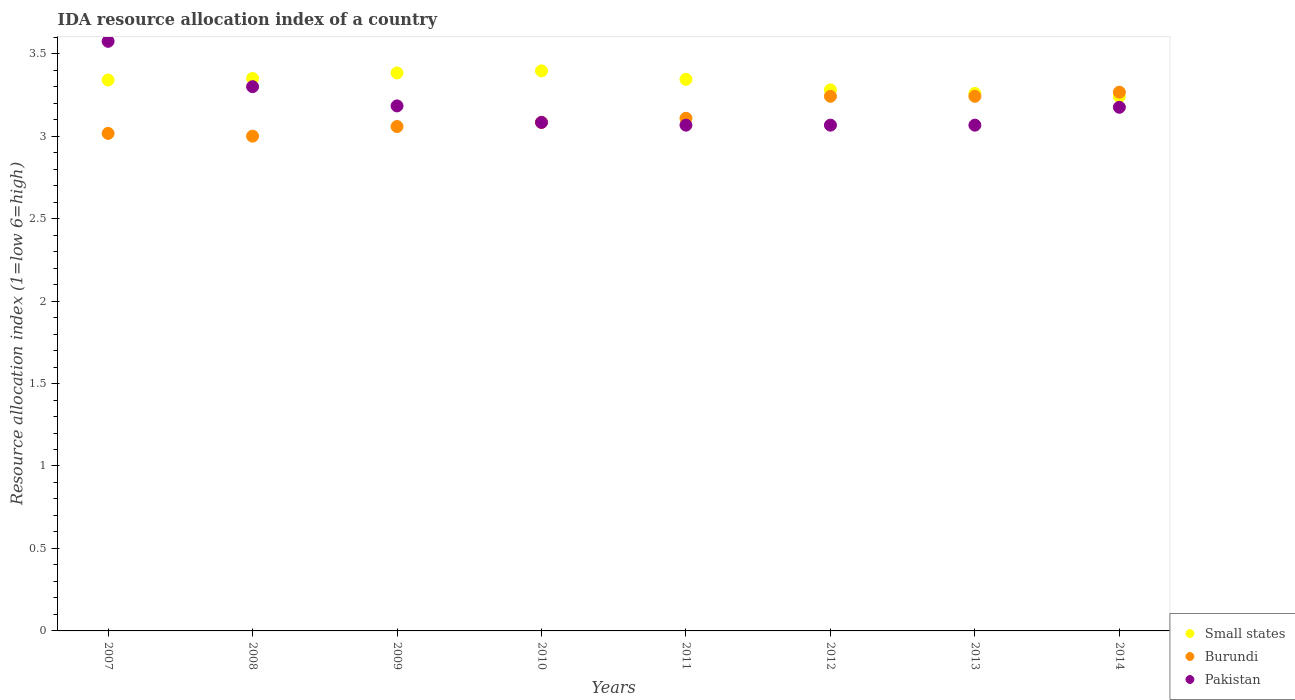How many different coloured dotlines are there?
Make the answer very short. 3. What is the IDA resource allocation index in Pakistan in 2012?
Provide a short and direct response. 3.07. Across all years, what is the maximum IDA resource allocation index in Burundi?
Keep it short and to the point. 3.27. Across all years, what is the minimum IDA resource allocation index in Burundi?
Your answer should be compact. 3. What is the total IDA resource allocation index in Pakistan in the graph?
Your answer should be compact. 25.52. What is the difference between the IDA resource allocation index in Burundi in 2008 and that in 2013?
Provide a short and direct response. -0.24. What is the difference between the IDA resource allocation index in Small states in 2007 and the IDA resource allocation index in Burundi in 2008?
Offer a terse response. 0.34. What is the average IDA resource allocation index in Burundi per year?
Provide a short and direct response. 3.13. In the year 2010, what is the difference between the IDA resource allocation index in Burundi and IDA resource allocation index in Pakistan?
Give a very brief answer. 0. What is the ratio of the IDA resource allocation index in Pakistan in 2009 to that in 2014?
Your answer should be very brief. 1. Is the IDA resource allocation index in Pakistan in 2008 less than that in 2014?
Offer a very short reply. No. Is the difference between the IDA resource allocation index in Burundi in 2011 and 2012 greater than the difference between the IDA resource allocation index in Pakistan in 2011 and 2012?
Ensure brevity in your answer.  No. What is the difference between the highest and the second highest IDA resource allocation index in Pakistan?
Offer a very short reply. 0.28. What is the difference between the highest and the lowest IDA resource allocation index in Small states?
Provide a succinct answer. 0.16. In how many years, is the IDA resource allocation index in Pakistan greater than the average IDA resource allocation index in Pakistan taken over all years?
Make the answer very short. 2. Is the sum of the IDA resource allocation index in Burundi in 2008 and 2013 greater than the maximum IDA resource allocation index in Pakistan across all years?
Offer a terse response. Yes. Is it the case that in every year, the sum of the IDA resource allocation index in Small states and IDA resource allocation index in Burundi  is greater than the IDA resource allocation index in Pakistan?
Your answer should be compact. Yes. Does the IDA resource allocation index in Pakistan monotonically increase over the years?
Your answer should be very brief. No. Is the IDA resource allocation index in Small states strictly greater than the IDA resource allocation index in Pakistan over the years?
Offer a terse response. No. How many dotlines are there?
Your response must be concise. 3. What is the difference between two consecutive major ticks on the Y-axis?
Provide a short and direct response. 0.5. Does the graph contain any zero values?
Make the answer very short. No. Does the graph contain grids?
Your response must be concise. No. Where does the legend appear in the graph?
Make the answer very short. Bottom right. How many legend labels are there?
Provide a short and direct response. 3. What is the title of the graph?
Provide a succinct answer. IDA resource allocation index of a country. Does "Malta" appear as one of the legend labels in the graph?
Offer a terse response. No. What is the label or title of the Y-axis?
Your answer should be very brief. Resource allocation index (1=low 6=high). What is the Resource allocation index (1=low 6=high) of Small states in 2007?
Give a very brief answer. 3.34. What is the Resource allocation index (1=low 6=high) of Burundi in 2007?
Your answer should be very brief. 3.02. What is the Resource allocation index (1=low 6=high) of Pakistan in 2007?
Offer a very short reply. 3.58. What is the Resource allocation index (1=low 6=high) of Small states in 2008?
Offer a very short reply. 3.35. What is the Resource allocation index (1=low 6=high) of Burundi in 2008?
Provide a succinct answer. 3. What is the Resource allocation index (1=low 6=high) in Pakistan in 2008?
Provide a short and direct response. 3.3. What is the Resource allocation index (1=low 6=high) of Small states in 2009?
Provide a short and direct response. 3.38. What is the Resource allocation index (1=low 6=high) of Burundi in 2009?
Offer a terse response. 3.06. What is the Resource allocation index (1=low 6=high) of Pakistan in 2009?
Your response must be concise. 3.18. What is the Resource allocation index (1=low 6=high) in Small states in 2010?
Ensure brevity in your answer.  3.4. What is the Resource allocation index (1=low 6=high) of Burundi in 2010?
Offer a terse response. 3.08. What is the Resource allocation index (1=low 6=high) of Pakistan in 2010?
Your response must be concise. 3.08. What is the Resource allocation index (1=low 6=high) in Small states in 2011?
Offer a very short reply. 3.34. What is the Resource allocation index (1=low 6=high) of Burundi in 2011?
Your answer should be compact. 3.11. What is the Resource allocation index (1=low 6=high) in Pakistan in 2011?
Give a very brief answer. 3.07. What is the Resource allocation index (1=low 6=high) of Small states in 2012?
Offer a very short reply. 3.28. What is the Resource allocation index (1=low 6=high) in Burundi in 2012?
Your answer should be very brief. 3.24. What is the Resource allocation index (1=low 6=high) of Pakistan in 2012?
Give a very brief answer. 3.07. What is the Resource allocation index (1=low 6=high) in Small states in 2013?
Offer a very short reply. 3.26. What is the Resource allocation index (1=low 6=high) of Burundi in 2013?
Offer a very short reply. 3.24. What is the Resource allocation index (1=low 6=high) of Pakistan in 2013?
Give a very brief answer. 3.07. What is the Resource allocation index (1=low 6=high) of Small states in 2014?
Offer a very short reply. 3.24. What is the Resource allocation index (1=low 6=high) in Burundi in 2014?
Keep it short and to the point. 3.27. What is the Resource allocation index (1=low 6=high) in Pakistan in 2014?
Offer a very short reply. 3.17. Across all years, what is the maximum Resource allocation index (1=low 6=high) in Small states?
Your answer should be compact. 3.4. Across all years, what is the maximum Resource allocation index (1=low 6=high) of Burundi?
Your answer should be very brief. 3.27. Across all years, what is the maximum Resource allocation index (1=low 6=high) of Pakistan?
Keep it short and to the point. 3.58. Across all years, what is the minimum Resource allocation index (1=low 6=high) in Small states?
Your answer should be very brief. 3.24. Across all years, what is the minimum Resource allocation index (1=low 6=high) of Pakistan?
Your answer should be very brief. 3.07. What is the total Resource allocation index (1=low 6=high) of Small states in the graph?
Your answer should be compact. 26.59. What is the total Resource allocation index (1=low 6=high) of Burundi in the graph?
Keep it short and to the point. 25.02. What is the total Resource allocation index (1=low 6=high) of Pakistan in the graph?
Provide a succinct answer. 25.52. What is the difference between the Resource allocation index (1=low 6=high) in Small states in 2007 and that in 2008?
Ensure brevity in your answer.  -0.01. What is the difference between the Resource allocation index (1=low 6=high) in Burundi in 2007 and that in 2008?
Your answer should be compact. 0.02. What is the difference between the Resource allocation index (1=low 6=high) of Pakistan in 2007 and that in 2008?
Keep it short and to the point. 0.28. What is the difference between the Resource allocation index (1=low 6=high) of Small states in 2007 and that in 2009?
Ensure brevity in your answer.  -0.04. What is the difference between the Resource allocation index (1=low 6=high) in Burundi in 2007 and that in 2009?
Provide a succinct answer. -0.04. What is the difference between the Resource allocation index (1=low 6=high) in Pakistan in 2007 and that in 2009?
Offer a very short reply. 0.39. What is the difference between the Resource allocation index (1=low 6=high) of Small states in 2007 and that in 2010?
Offer a terse response. -0.06. What is the difference between the Resource allocation index (1=low 6=high) of Burundi in 2007 and that in 2010?
Ensure brevity in your answer.  -0.07. What is the difference between the Resource allocation index (1=low 6=high) in Pakistan in 2007 and that in 2010?
Your answer should be compact. 0.49. What is the difference between the Resource allocation index (1=low 6=high) in Small states in 2007 and that in 2011?
Ensure brevity in your answer.  -0. What is the difference between the Resource allocation index (1=low 6=high) in Burundi in 2007 and that in 2011?
Offer a terse response. -0.09. What is the difference between the Resource allocation index (1=low 6=high) in Pakistan in 2007 and that in 2011?
Give a very brief answer. 0.51. What is the difference between the Resource allocation index (1=low 6=high) in Small states in 2007 and that in 2012?
Offer a terse response. 0.06. What is the difference between the Resource allocation index (1=low 6=high) in Burundi in 2007 and that in 2012?
Your answer should be compact. -0.23. What is the difference between the Resource allocation index (1=low 6=high) in Pakistan in 2007 and that in 2012?
Your answer should be very brief. 0.51. What is the difference between the Resource allocation index (1=low 6=high) of Small states in 2007 and that in 2013?
Ensure brevity in your answer.  0.08. What is the difference between the Resource allocation index (1=low 6=high) of Burundi in 2007 and that in 2013?
Offer a terse response. -0.23. What is the difference between the Resource allocation index (1=low 6=high) in Pakistan in 2007 and that in 2013?
Your answer should be compact. 0.51. What is the difference between the Resource allocation index (1=low 6=high) of Small states in 2007 and that in 2014?
Provide a succinct answer. 0.1. What is the difference between the Resource allocation index (1=low 6=high) in Burundi in 2007 and that in 2014?
Offer a very short reply. -0.25. What is the difference between the Resource allocation index (1=low 6=high) in Pakistan in 2007 and that in 2014?
Make the answer very short. 0.4. What is the difference between the Resource allocation index (1=low 6=high) of Small states in 2008 and that in 2009?
Keep it short and to the point. -0.03. What is the difference between the Resource allocation index (1=low 6=high) in Burundi in 2008 and that in 2009?
Provide a short and direct response. -0.06. What is the difference between the Resource allocation index (1=low 6=high) of Pakistan in 2008 and that in 2009?
Your response must be concise. 0.12. What is the difference between the Resource allocation index (1=low 6=high) of Small states in 2008 and that in 2010?
Your answer should be compact. -0.05. What is the difference between the Resource allocation index (1=low 6=high) of Burundi in 2008 and that in 2010?
Offer a terse response. -0.08. What is the difference between the Resource allocation index (1=low 6=high) of Pakistan in 2008 and that in 2010?
Give a very brief answer. 0.22. What is the difference between the Resource allocation index (1=low 6=high) in Small states in 2008 and that in 2011?
Your answer should be very brief. 0.01. What is the difference between the Resource allocation index (1=low 6=high) in Burundi in 2008 and that in 2011?
Offer a terse response. -0.11. What is the difference between the Resource allocation index (1=low 6=high) in Pakistan in 2008 and that in 2011?
Keep it short and to the point. 0.23. What is the difference between the Resource allocation index (1=low 6=high) in Small states in 2008 and that in 2012?
Offer a very short reply. 0.07. What is the difference between the Resource allocation index (1=low 6=high) in Burundi in 2008 and that in 2012?
Your answer should be very brief. -0.24. What is the difference between the Resource allocation index (1=low 6=high) of Pakistan in 2008 and that in 2012?
Provide a succinct answer. 0.23. What is the difference between the Resource allocation index (1=low 6=high) in Small states in 2008 and that in 2013?
Offer a terse response. 0.09. What is the difference between the Resource allocation index (1=low 6=high) in Burundi in 2008 and that in 2013?
Keep it short and to the point. -0.24. What is the difference between the Resource allocation index (1=low 6=high) in Pakistan in 2008 and that in 2013?
Offer a terse response. 0.23. What is the difference between the Resource allocation index (1=low 6=high) of Small states in 2008 and that in 2014?
Give a very brief answer. 0.11. What is the difference between the Resource allocation index (1=low 6=high) of Burundi in 2008 and that in 2014?
Give a very brief answer. -0.27. What is the difference between the Resource allocation index (1=low 6=high) in Pakistan in 2008 and that in 2014?
Keep it short and to the point. 0.12. What is the difference between the Resource allocation index (1=low 6=high) of Small states in 2009 and that in 2010?
Your answer should be very brief. -0.01. What is the difference between the Resource allocation index (1=low 6=high) in Burundi in 2009 and that in 2010?
Your response must be concise. -0.03. What is the difference between the Resource allocation index (1=low 6=high) of Pakistan in 2009 and that in 2010?
Provide a short and direct response. 0.1. What is the difference between the Resource allocation index (1=low 6=high) of Small states in 2009 and that in 2011?
Your answer should be compact. 0.04. What is the difference between the Resource allocation index (1=low 6=high) of Pakistan in 2009 and that in 2011?
Provide a short and direct response. 0.12. What is the difference between the Resource allocation index (1=low 6=high) in Small states in 2009 and that in 2012?
Give a very brief answer. 0.1. What is the difference between the Resource allocation index (1=low 6=high) of Burundi in 2009 and that in 2012?
Your response must be concise. -0.18. What is the difference between the Resource allocation index (1=low 6=high) in Pakistan in 2009 and that in 2012?
Your response must be concise. 0.12. What is the difference between the Resource allocation index (1=low 6=high) in Small states in 2009 and that in 2013?
Make the answer very short. 0.12. What is the difference between the Resource allocation index (1=low 6=high) in Burundi in 2009 and that in 2013?
Offer a terse response. -0.18. What is the difference between the Resource allocation index (1=low 6=high) in Pakistan in 2009 and that in 2013?
Offer a terse response. 0.12. What is the difference between the Resource allocation index (1=low 6=high) of Small states in 2009 and that in 2014?
Provide a short and direct response. 0.14. What is the difference between the Resource allocation index (1=low 6=high) of Burundi in 2009 and that in 2014?
Keep it short and to the point. -0.21. What is the difference between the Resource allocation index (1=low 6=high) of Pakistan in 2009 and that in 2014?
Make the answer very short. 0.01. What is the difference between the Resource allocation index (1=low 6=high) in Small states in 2010 and that in 2011?
Your answer should be compact. 0.05. What is the difference between the Resource allocation index (1=low 6=high) in Burundi in 2010 and that in 2011?
Offer a very short reply. -0.03. What is the difference between the Resource allocation index (1=low 6=high) in Pakistan in 2010 and that in 2011?
Give a very brief answer. 0.02. What is the difference between the Resource allocation index (1=low 6=high) in Small states in 2010 and that in 2012?
Keep it short and to the point. 0.12. What is the difference between the Resource allocation index (1=low 6=high) in Burundi in 2010 and that in 2012?
Your answer should be very brief. -0.16. What is the difference between the Resource allocation index (1=low 6=high) in Pakistan in 2010 and that in 2012?
Your response must be concise. 0.02. What is the difference between the Resource allocation index (1=low 6=high) in Small states in 2010 and that in 2013?
Offer a terse response. 0.14. What is the difference between the Resource allocation index (1=low 6=high) of Burundi in 2010 and that in 2013?
Your answer should be very brief. -0.16. What is the difference between the Resource allocation index (1=low 6=high) of Pakistan in 2010 and that in 2013?
Provide a succinct answer. 0.02. What is the difference between the Resource allocation index (1=low 6=high) in Small states in 2010 and that in 2014?
Offer a terse response. 0.16. What is the difference between the Resource allocation index (1=low 6=high) of Burundi in 2010 and that in 2014?
Provide a succinct answer. -0.18. What is the difference between the Resource allocation index (1=low 6=high) in Pakistan in 2010 and that in 2014?
Keep it short and to the point. -0.09. What is the difference between the Resource allocation index (1=low 6=high) of Small states in 2011 and that in 2012?
Offer a very short reply. 0.06. What is the difference between the Resource allocation index (1=low 6=high) in Burundi in 2011 and that in 2012?
Make the answer very short. -0.13. What is the difference between the Resource allocation index (1=low 6=high) of Small states in 2011 and that in 2013?
Your answer should be very brief. 0.09. What is the difference between the Resource allocation index (1=low 6=high) in Burundi in 2011 and that in 2013?
Your response must be concise. -0.13. What is the difference between the Resource allocation index (1=low 6=high) in Pakistan in 2011 and that in 2013?
Your response must be concise. 0. What is the difference between the Resource allocation index (1=low 6=high) in Small states in 2011 and that in 2014?
Provide a succinct answer. 0.1. What is the difference between the Resource allocation index (1=low 6=high) in Burundi in 2011 and that in 2014?
Your response must be concise. -0.16. What is the difference between the Resource allocation index (1=low 6=high) in Pakistan in 2011 and that in 2014?
Make the answer very short. -0.11. What is the difference between the Resource allocation index (1=low 6=high) of Small states in 2012 and that in 2013?
Offer a terse response. 0.02. What is the difference between the Resource allocation index (1=low 6=high) in Small states in 2012 and that in 2014?
Provide a succinct answer. 0.04. What is the difference between the Resource allocation index (1=low 6=high) in Burundi in 2012 and that in 2014?
Provide a short and direct response. -0.03. What is the difference between the Resource allocation index (1=low 6=high) in Pakistan in 2012 and that in 2014?
Ensure brevity in your answer.  -0.11. What is the difference between the Resource allocation index (1=low 6=high) in Small states in 2013 and that in 2014?
Your answer should be very brief. 0.02. What is the difference between the Resource allocation index (1=low 6=high) of Burundi in 2013 and that in 2014?
Provide a short and direct response. -0.03. What is the difference between the Resource allocation index (1=low 6=high) in Pakistan in 2013 and that in 2014?
Your answer should be compact. -0.11. What is the difference between the Resource allocation index (1=low 6=high) of Small states in 2007 and the Resource allocation index (1=low 6=high) of Burundi in 2008?
Offer a very short reply. 0.34. What is the difference between the Resource allocation index (1=low 6=high) of Small states in 2007 and the Resource allocation index (1=low 6=high) of Pakistan in 2008?
Your answer should be very brief. 0.04. What is the difference between the Resource allocation index (1=low 6=high) of Burundi in 2007 and the Resource allocation index (1=low 6=high) of Pakistan in 2008?
Your response must be concise. -0.28. What is the difference between the Resource allocation index (1=low 6=high) of Small states in 2007 and the Resource allocation index (1=low 6=high) of Burundi in 2009?
Provide a succinct answer. 0.28. What is the difference between the Resource allocation index (1=low 6=high) of Small states in 2007 and the Resource allocation index (1=low 6=high) of Pakistan in 2009?
Your response must be concise. 0.16. What is the difference between the Resource allocation index (1=low 6=high) of Burundi in 2007 and the Resource allocation index (1=low 6=high) of Pakistan in 2009?
Give a very brief answer. -0.17. What is the difference between the Resource allocation index (1=low 6=high) of Small states in 2007 and the Resource allocation index (1=low 6=high) of Burundi in 2010?
Your answer should be very brief. 0.26. What is the difference between the Resource allocation index (1=low 6=high) in Small states in 2007 and the Resource allocation index (1=low 6=high) in Pakistan in 2010?
Provide a succinct answer. 0.26. What is the difference between the Resource allocation index (1=low 6=high) of Burundi in 2007 and the Resource allocation index (1=low 6=high) of Pakistan in 2010?
Your response must be concise. -0.07. What is the difference between the Resource allocation index (1=low 6=high) in Small states in 2007 and the Resource allocation index (1=low 6=high) in Burundi in 2011?
Ensure brevity in your answer.  0.23. What is the difference between the Resource allocation index (1=low 6=high) of Small states in 2007 and the Resource allocation index (1=low 6=high) of Pakistan in 2011?
Your answer should be compact. 0.27. What is the difference between the Resource allocation index (1=low 6=high) of Small states in 2007 and the Resource allocation index (1=low 6=high) of Burundi in 2012?
Offer a very short reply. 0.1. What is the difference between the Resource allocation index (1=low 6=high) in Small states in 2007 and the Resource allocation index (1=low 6=high) in Pakistan in 2012?
Offer a terse response. 0.27. What is the difference between the Resource allocation index (1=low 6=high) of Burundi in 2007 and the Resource allocation index (1=low 6=high) of Pakistan in 2012?
Provide a succinct answer. -0.05. What is the difference between the Resource allocation index (1=low 6=high) of Small states in 2007 and the Resource allocation index (1=low 6=high) of Burundi in 2013?
Offer a very short reply. 0.1. What is the difference between the Resource allocation index (1=low 6=high) in Small states in 2007 and the Resource allocation index (1=low 6=high) in Pakistan in 2013?
Your answer should be very brief. 0.27. What is the difference between the Resource allocation index (1=low 6=high) in Burundi in 2007 and the Resource allocation index (1=low 6=high) in Pakistan in 2013?
Provide a short and direct response. -0.05. What is the difference between the Resource allocation index (1=low 6=high) of Small states in 2007 and the Resource allocation index (1=low 6=high) of Burundi in 2014?
Give a very brief answer. 0.07. What is the difference between the Resource allocation index (1=low 6=high) of Small states in 2007 and the Resource allocation index (1=low 6=high) of Pakistan in 2014?
Ensure brevity in your answer.  0.17. What is the difference between the Resource allocation index (1=low 6=high) of Burundi in 2007 and the Resource allocation index (1=low 6=high) of Pakistan in 2014?
Provide a short and direct response. -0.16. What is the difference between the Resource allocation index (1=low 6=high) in Small states in 2008 and the Resource allocation index (1=low 6=high) in Burundi in 2009?
Keep it short and to the point. 0.29. What is the difference between the Resource allocation index (1=low 6=high) in Small states in 2008 and the Resource allocation index (1=low 6=high) in Pakistan in 2009?
Give a very brief answer. 0.17. What is the difference between the Resource allocation index (1=low 6=high) of Burundi in 2008 and the Resource allocation index (1=low 6=high) of Pakistan in 2009?
Ensure brevity in your answer.  -0.18. What is the difference between the Resource allocation index (1=low 6=high) in Small states in 2008 and the Resource allocation index (1=low 6=high) in Burundi in 2010?
Ensure brevity in your answer.  0.27. What is the difference between the Resource allocation index (1=low 6=high) in Small states in 2008 and the Resource allocation index (1=low 6=high) in Pakistan in 2010?
Offer a terse response. 0.27. What is the difference between the Resource allocation index (1=low 6=high) of Burundi in 2008 and the Resource allocation index (1=low 6=high) of Pakistan in 2010?
Your answer should be compact. -0.08. What is the difference between the Resource allocation index (1=low 6=high) in Small states in 2008 and the Resource allocation index (1=low 6=high) in Burundi in 2011?
Offer a very short reply. 0.24. What is the difference between the Resource allocation index (1=low 6=high) of Small states in 2008 and the Resource allocation index (1=low 6=high) of Pakistan in 2011?
Provide a succinct answer. 0.28. What is the difference between the Resource allocation index (1=low 6=high) in Burundi in 2008 and the Resource allocation index (1=low 6=high) in Pakistan in 2011?
Ensure brevity in your answer.  -0.07. What is the difference between the Resource allocation index (1=low 6=high) of Small states in 2008 and the Resource allocation index (1=low 6=high) of Burundi in 2012?
Your answer should be very brief. 0.11. What is the difference between the Resource allocation index (1=low 6=high) in Small states in 2008 and the Resource allocation index (1=low 6=high) in Pakistan in 2012?
Your answer should be compact. 0.28. What is the difference between the Resource allocation index (1=low 6=high) of Burundi in 2008 and the Resource allocation index (1=low 6=high) of Pakistan in 2012?
Make the answer very short. -0.07. What is the difference between the Resource allocation index (1=low 6=high) in Small states in 2008 and the Resource allocation index (1=low 6=high) in Burundi in 2013?
Provide a succinct answer. 0.11. What is the difference between the Resource allocation index (1=low 6=high) in Small states in 2008 and the Resource allocation index (1=low 6=high) in Pakistan in 2013?
Your answer should be compact. 0.28. What is the difference between the Resource allocation index (1=low 6=high) of Burundi in 2008 and the Resource allocation index (1=low 6=high) of Pakistan in 2013?
Offer a terse response. -0.07. What is the difference between the Resource allocation index (1=low 6=high) of Small states in 2008 and the Resource allocation index (1=low 6=high) of Burundi in 2014?
Your answer should be very brief. 0.08. What is the difference between the Resource allocation index (1=low 6=high) in Small states in 2008 and the Resource allocation index (1=low 6=high) in Pakistan in 2014?
Ensure brevity in your answer.  0.17. What is the difference between the Resource allocation index (1=low 6=high) in Burundi in 2008 and the Resource allocation index (1=low 6=high) in Pakistan in 2014?
Make the answer very short. -0.17. What is the difference between the Resource allocation index (1=low 6=high) of Small states in 2009 and the Resource allocation index (1=low 6=high) of Burundi in 2010?
Ensure brevity in your answer.  0.3. What is the difference between the Resource allocation index (1=low 6=high) in Small states in 2009 and the Resource allocation index (1=low 6=high) in Pakistan in 2010?
Provide a short and direct response. 0.3. What is the difference between the Resource allocation index (1=low 6=high) in Burundi in 2009 and the Resource allocation index (1=low 6=high) in Pakistan in 2010?
Your answer should be compact. -0.03. What is the difference between the Resource allocation index (1=low 6=high) in Small states in 2009 and the Resource allocation index (1=low 6=high) in Burundi in 2011?
Keep it short and to the point. 0.28. What is the difference between the Resource allocation index (1=low 6=high) in Small states in 2009 and the Resource allocation index (1=low 6=high) in Pakistan in 2011?
Offer a very short reply. 0.32. What is the difference between the Resource allocation index (1=low 6=high) in Burundi in 2009 and the Resource allocation index (1=low 6=high) in Pakistan in 2011?
Your answer should be compact. -0.01. What is the difference between the Resource allocation index (1=low 6=high) of Small states in 2009 and the Resource allocation index (1=low 6=high) of Burundi in 2012?
Your answer should be compact. 0.14. What is the difference between the Resource allocation index (1=low 6=high) of Small states in 2009 and the Resource allocation index (1=low 6=high) of Pakistan in 2012?
Make the answer very short. 0.32. What is the difference between the Resource allocation index (1=low 6=high) in Burundi in 2009 and the Resource allocation index (1=low 6=high) in Pakistan in 2012?
Keep it short and to the point. -0.01. What is the difference between the Resource allocation index (1=low 6=high) of Small states in 2009 and the Resource allocation index (1=low 6=high) of Burundi in 2013?
Offer a terse response. 0.14. What is the difference between the Resource allocation index (1=low 6=high) in Small states in 2009 and the Resource allocation index (1=low 6=high) in Pakistan in 2013?
Keep it short and to the point. 0.32. What is the difference between the Resource allocation index (1=low 6=high) of Burundi in 2009 and the Resource allocation index (1=low 6=high) of Pakistan in 2013?
Keep it short and to the point. -0.01. What is the difference between the Resource allocation index (1=low 6=high) in Small states in 2009 and the Resource allocation index (1=low 6=high) in Burundi in 2014?
Offer a terse response. 0.12. What is the difference between the Resource allocation index (1=low 6=high) of Small states in 2009 and the Resource allocation index (1=low 6=high) of Pakistan in 2014?
Offer a terse response. 0.21. What is the difference between the Resource allocation index (1=low 6=high) in Burundi in 2009 and the Resource allocation index (1=low 6=high) in Pakistan in 2014?
Your response must be concise. -0.12. What is the difference between the Resource allocation index (1=low 6=high) of Small states in 2010 and the Resource allocation index (1=low 6=high) of Burundi in 2011?
Your response must be concise. 0.29. What is the difference between the Resource allocation index (1=low 6=high) of Small states in 2010 and the Resource allocation index (1=low 6=high) of Pakistan in 2011?
Keep it short and to the point. 0.33. What is the difference between the Resource allocation index (1=low 6=high) in Burundi in 2010 and the Resource allocation index (1=low 6=high) in Pakistan in 2011?
Your answer should be very brief. 0.02. What is the difference between the Resource allocation index (1=low 6=high) of Small states in 2010 and the Resource allocation index (1=low 6=high) of Burundi in 2012?
Provide a succinct answer. 0.15. What is the difference between the Resource allocation index (1=low 6=high) in Small states in 2010 and the Resource allocation index (1=low 6=high) in Pakistan in 2012?
Provide a succinct answer. 0.33. What is the difference between the Resource allocation index (1=low 6=high) in Burundi in 2010 and the Resource allocation index (1=low 6=high) in Pakistan in 2012?
Ensure brevity in your answer.  0.02. What is the difference between the Resource allocation index (1=low 6=high) in Small states in 2010 and the Resource allocation index (1=low 6=high) in Burundi in 2013?
Give a very brief answer. 0.15. What is the difference between the Resource allocation index (1=low 6=high) of Small states in 2010 and the Resource allocation index (1=low 6=high) of Pakistan in 2013?
Give a very brief answer. 0.33. What is the difference between the Resource allocation index (1=low 6=high) of Burundi in 2010 and the Resource allocation index (1=low 6=high) of Pakistan in 2013?
Ensure brevity in your answer.  0.02. What is the difference between the Resource allocation index (1=low 6=high) in Small states in 2010 and the Resource allocation index (1=low 6=high) in Burundi in 2014?
Offer a terse response. 0.13. What is the difference between the Resource allocation index (1=low 6=high) in Small states in 2010 and the Resource allocation index (1=low 6=high) in Pakistan in 2014?
Offer a very short reply. 0.22. What is the difference between the Resource allocation index (1=low 6=high) of Burundi in 2010 and the Resource allocation index (1=low 6=high) of Pakistan in 2014?
Make the answer very short. -0.09. What is the difference between the Resource allocation index (1=low 6=high) in Small states in 2011 and the Resource allocation index (1=low 6=high) in Burundi in 2012?
Your answer should be compact. 0.1. What is the difference between the Resource allocation index (1=low 6=high) of Small states in 2011 and the Resource allocation index (1=low 6=high) of Pakistan in 2012?
Give a very brief answer. 0.28. What is the difference between the Resource allocation index (1=low 6=high) of Burundi in 2011 and the Resource allocation index (1=low 6=high) of Pakistan in 2012?
Offer a very short reply. 0.04. What is the difference between the Resource allocation index (1=low 6=high) in Small states in 2011 and the Resource allocation index (1=low 6=high) in Burundi in 2013?
Your response must be concise. 0.1. What is the difference between the Resource allocation index (1=low 6=high) in Small states in 2011 and the Resource allocation index (1=low 6=high) in Pakistan in 2013?
Give a very brief answer. 0.28. What is the difference between the Resource allocation index (1=low 6=high) of Burundi in 2011 and the Resource allocation index (1=low 6=high) of Pakistan in 2013?
Ensure brevity in your answer.  0.04. What is the difference between the Resource allocation index (1=low 6=high) in Small states in 2011 and the Resource allocation index (1=low 6=high) in Burundi in 2014?
Offer a terse response. 0.08. What is the difference between the Resource allocation index (1=low 6=high) of Small states in 2011 and the Resource allocation index (1=low 6=high) of Pakistan in 2014?
Provide a short and direct response. 0.17. What is the difference between the Resource allocation index (1=low 6=high) in Burundi in 2011 and the Resource allocation index (1=low 6=high) in Pakistan in 2014?
Your response must be concise. -0.07. What is the difference between the Resource allocation index (1=low 6=high) of Small states in 2012 and the Resource allocation index (1=low 6=high) of Burundi in 2013?
Ensure brevity in your answer.  0.04. What is the difference between the Resource allocation index (1=low 6=high) of Small states in 2012 and the Resource allocation index (1=low 6=high) of Pakistan in 2013?
Offer a terse response. 0.21. What is the difference between the Resource allocation index (1=low 6=high) of Burundi in 2012 and the Resource allocation index (1=low 6=high) of Pakistan in 2013?
Keep it short and to the point. 0.17. What is the difference between the Resource allocation index (1=low 6=high) in Small states in 2012 and the Resource allocation index (1=low 6=high) in Burundi in 2014?
Ensure brevity in your answer.  0.01. What is the difference between the Resource allocation index (1=low 6=high) in Small states in 2012 and the Resource allocation index (1=low 6=high) in Pakistan in 2014?
Provide a succinct answer. 0.11. What is the difference between the Resource allocation index (1=low 6=high) in Burundi in 2012 and the Resource allocation index (1=low 6=high) in Pakistan in 2014?
Your answer should be very brief. 0.07. What is the difference between the Resource allocation index (1=low 6=high) in Small states in 2013 and the Resource allocation index (1=low 6=high) in Burundi in 2014?
Your answer should be very brief. -0.01. What is the difference between the Resource allocation index (1=low 6=high) of Small states in 2013 and the Resource allocation index (1=low 6=high) of Pakistan in 2014?
Your response must be concise. 0.08. What is the difference between the Resource allocation index (1=low 6=high) of Burundi in 2013 and the Resource allocation index (1=low 6=high) of Pakistan in 2014?
Keep it short and to the point. 0.07. What is the average Resource allocation index (1=low 6=high) of Small states per year?
Make the answer very short. 3.32. What is the average Resource allocation index (1=low 6=high) of Burundi per year?
Your answer should be very brief. 3.13. What is the average Resource allocation index (1=low 6=high) of Pakistan per year?
Your answer should be compact. 3.19. In the year 2007, what is the difference between the Resource allocation index (1=low 6=high) of Small states and Resource allocation index (1=low 6=high) of Burundi?
Offer a very short reply. 0.32. In the year 2007, what is the difference between the Resource allocation index (1=low 6=high) of Small states and Resource allocation index (1=low 6=high) of Pakistan?
Give a very brief answer. -0.23. In the year 2007, what is the difference between the Resource allocation index (1=low 6=high) in Burundi and Resource allocation index (1=low 6=high) in Pakistan?
Make the answer very short. -0.56. In the year 2009, what is the difference between the Resource allocation index (1=low 6=high) in Small states and Resource allocation index (1=low 6=high) in Burundi?
Make the answer very short. 0.33. In the year 2009, what is the difference between the Resource allocation index (1=low 6=high) of Burundi and Resource allocation index (1=low 6=high) of Pakistan?
Ensure brevity in your answer.  -0.12. In the year 2010, what is the difference between the Resource allocation index (1=low 6=high) in Small states and Resource allocation index (1=low 6=high) in Burundi?
Offer a terse response. 0.31. In the year 2010, what is the difference between the Resource allocation index (1=low 6=high) of Small states and Resource allocation index (1=low 6=high) of Pakistan?
Ensure brevity in your answer.  0.31. In the year 2010, what is the difference between the Resource allocation index (1=low 6=high) in Burundi and Resource allocation index (1=low 6=high) in Pakistan?
Offer a terse response. 0. In the year 2011, what is the difference between the Resource allocation index (1=low 6=high) in Small states and Resource allocation index (1=low 6=high) in Burundi?
Provide a succinct answer. 0.24. In the year 2011, what is the difference between the Resource allocation index (1=low 6=high) of Small states and Resource allocation index (1=low 6=high) of Pakistan?
Provide a succinct answer. 0.28. In the year 2011, what is the difference between the Resource allocation index (1=low 6=high) of Burundi and Resource allocation index (1=low 6=high) of Pakistan?
Provide a short and direct response. 0.04. In the year 2012, what is the difference between the Resource allocation index (1=low 6=high) of Small states and Resource allocation index (1=low 6=high) of Burundi?
Ensure brevity in your answer.  0.04. In the year 2012, what is the difference between the Resource allocation index (1=low 6=high) of Small states and Resource allocation index (1=low 6=high) of Pakistan?
Give a very brief answer. 0.21. In the year 2012, what is the difference between the Resource allocation index (1=low 6=high) of Burundi and Resource allocation index (1=low 6=high) of Pakistan?
Your answer should be compact. 0.17. In the year 2013, what is the difference between the Resource allocation index (1=low 6=high) in Small states and Resource allocation index (1=low 6=high) in Burundi?
Make the answer very short. 0.02. In the year 2013, what is the difference between the Resource allocation index (1=low 6=high) in Small states and Resource allocation index (1=low 6=high) in Pakistan?
Your answer should be compact. 0.19. In the year 2013, what is the difference between the Resource allocation index (1=low 6=high) of Burundi and Resource allocation index (1=low 6=high) of Pakistan?
Make the answer very short. 0.17. In the year 2014, what is the difference between the Resource allocation index (1=low 6=high) in Small states and Resource allocation index (1=low 6=high) in Burundi?
Make the answer very short. -0.03. In the year 2014, what is the difference between the Resource allocation index (1=low 6=high) of Small states and Resource allocation index (1=low 6=high) of Pakistan?
Make the answer very short. 0.06. In the year 2014, what is the difference between the Resource allocation index (1=low 6=high) of Burundi and Resource allocation index (1=low 6=high) of Pakistan?
Your answer should be very brief. 0.09. What is the ratio of the Resource allocation index (1=low 6=high) of Small states in 2007 to that in 2008?
Your answer should be very brief. 1. What is the ratio of the Resource allocation index (1=low 6=high) of Burundi in 2007 to that in 2008?
Provide a short and direct response. 1.01. What is the ratio of the Resource allocation index (1=low 6=high) of Pakistan in 2007 to that in 2008?
Keep it short and to the point. 1.08. What is the ratio of the Resource allocation index (1=low 6=high) in Small states in 2007 to that in 2009?
Your response must be concise. 0.99. What is the ratio of the Resource allocation index (1=low 6=high) in Burundi in 2007 to that in 2009?
Your answer should be compact. 0.99. What is the ratio of the Resource allocation index (1=low 6=high) of Pakistan in 2007 to that in 2009?
Your answer should be compact. 1.12. What is the ratio of the Resource allocation index (1=low 6=high) in Small states in 2007 to that in 2010?
Give a very brief answer. 0.98. What is the ratio of the Resource allocation index (1=low 6=high) of Burundi in 2007 to that in 2010?
Ensure brevity in your answer.  0.98. What is the ratio of the Resource allocation index (1=low 6=high) of Pakistan in 2007 to that in 2010?
Offer a terse response. 1.16. What is the ratio of the Resource allocation index (1=low 6=high) of Burundi in 2007 to that in 2011?
Ensure brevity in your answer.  0.97. What is the ratio of the Resource allocation index (1=low 6=high) of Pakistan in 2007 to that in 2011?
Your response must be concise. 1.17. What is the ratio of the Resource allocation index (1=low 6=high) of Small states in 2007 to that in 2012?
Your answer should be very brief. 1.02. What is the ratio of the Resource allocation index (1=low 6=high) in Burundi in 2007 to that in 2012?
Provide a short and direct response. 0.93. What is the ratio of the Resource allocation index (1=low 6=high) of Pakistan in 2007 to that in 2012?
Your response must be concise. 1.17. What is the ratio of the Resource allocation index (1=low 6=high) of Small states in 2007 to that in 2013?
Ensure brevity in your answer.  1.03. What is the ratio of the Resource allocation index (1=low 6=high) in Burundi in 2007 to that in 2013?
Offer a very short reply. 0.93. What is the ratio of the Resource allocation index (1=low 6=high) in Pakistan in 2007 to that in 2013?
Keep it short and to the point. 1.17. What is the ratio of the Resource allocation index (1=low 6=high) of Small states in 2007 to that in 2014?
Ensure brevity in your answer.  1.03. What is the ratio of the Resource allocation index (1=low 6=high) in Burundi in 2007 to that in 2014?
Give a very brief answer. 0.92. What is the ratio of the Resource allocation index (1=low 6=high) in Pakistan in 2007 to that in 2014?
Your answer should be compact. 1.13. What is the ratio of the Resource allocation index (1=low 6=high) in Small states in 2008 to that in 2009?
Provide a short and direct response. 0.99. What is the ratio of the Resource allocation index (1=low 6=high) in Burundi in 2008 to that in 2009?
Your answer should be very brief. 0.98. What is the ratio of the Resource allocation index (1=low 6=high) of Pakistan in 2008 to that in 2009?
Offer a very short reply. 1.04. What is the ratio of the Resource allocation index (1=low 6=high) of Small states in 2008 to that in 2010?
Offer a very short reply. 0.99. What is the ratio of the Resource allocation index (1=low 6=high) in Pakistan in 2008 to that in 2010?
Give a very brief answer. 1.07. What is the ratio of the Resource allocation index (1=low 6=high) of Burundi in 2008 to that in 2011?
Provide a short and direct response. 0.97. What is the ratio of the Resource allocation index (1=low 6=high) of Pakistan in 2008 to that in 2011?
Provide a succinct answer. 1.08. What is the ratio of the Resource allocation index (1=low 6=high) in Small states in 2008 to that in 2012?
Keep it short and to the point. 1.02. What is the ratio of the Resource allocation index (1=low 6=high) of Burundi in 2008 to that in 2012?
Offer a very short reply. 0.93. What is the ratio of the Resource allocation index (1=low 6=high) of Pakistan in 2008 to that in 2012?
Ensure brevity in your answer.  1.08. What is the ratio of the Resource allocation index (1=low 6=high) of Small states in 2008 to that in 2013?
Your response must be concise. 1.03. What is the ratio of the Resource allocation index (1=low 6=high) of Burundi in 2008 to that in 2013?
Provide a succinct answer. 0.93. What is the ratio of the Resource allocation index (1=low 6=high) in Pakistan in 2008 to that in 2013?
Your response must be concise. 1.08. What is the ratio of the Resource allocation index (1=low 6=high) of Small states in 2008 to that in 2014?
Offer a very short reply. 1.03. What is the ratio of the Resource allocation index (1=low 6=high) in Burundi in 2008 to that in 2014?
Provide a succinct answer. 0.92. What is the ratio of the Resource allocation index (1=low 6=high) of Pakistan in 2008 to that in 2014?
Offer a terse response. 1.04. What is the ratio of the Resource allocation index (1=low 6=high) of Small states in 2009 to that in 2010?
Offer a very short reply. 1. What is the ratio of the Resource allocation index (1=low 6=high) in Burundi in 2009 to that in 2010?
Keep it short and to the point. 0.99. What is the ratio of the Resource allocation index (1=low 6=high) in Pakistan in 2009 to that in 2010?
Your response must be concise. 1.03. What is the ratio of the Resource allocation index (1=low 6=high) in Small states in 2009 to that in 2011?
Your answer should be very brief. 1.01. What is the ratio of the Resource allocation index (1=low 6=high) in Burundi in 2009 to that in 2011?
Offer a terse response. 0.98. What is the ratio of the Resource allocation index (1=low 6=high) of Pakistan in 2009 to that in 2011?
Make the answer very short. 1.04. What is the ratio of the Resource allocation index (1=low 6=high) of Small states in 2009 to that in 2012?
Make the answer very short. 1.03. What is the ratio of the Resource allocation index (1=low 6=high) of Burundi in 2009 to that in 2012?
Your response must be concise. 0.94. What is the ratio of the Resource allocation index (1=low 6=high) of Pakistan in 2009 to that in 2012?
Provide a succinct answer. 1.04. What is the ratio of the Resource allocation index (1=low 6=high) of Small states in 2009 to that in 2013?
Provide a short and direct response. 1.04. What is the ratio of the Resource allocation index (1=low 6=high) of Burundi in 2009 to that in 2013?
Give a very brief answer. 0.94. What is the ratio of the Resource allocation index (1=low 6=high) in Pakistan in 2009 to that in 2013?
Give a very brief answer. 1.04. What is the ratio of the Resource allocation index (1=low 6=high) in Small states in 2009 to that in 2014?
Provide a succinct answer. 1.04. What is the ratio of the Resource allocation index (1=low 6=high) in Burundi in 2009 to that in 2014?
Your answer should be compact. 0.94. What is the ratio of the Resource allocation index (1=low 6=high) of Pakistan in 2009 to that in 2014?
Give a very brief answer. 1. What is the ratio of the Resource allocation index (1=low 6=high) in Small states in 2010 to that in 2011?
Provide a succinct answer. 1.02. What is the ratio of the Resource allocation index (1=low 6=high) of Burundi in 2010 to that in 2011?
Provide a succinct answer. 0.99. What is the ratio of the Resource allocation index (1=low 6=high) in Pakistan in 2010 to that in 2011?
Keep it short and to the point. 1.01. What is the ratio of the Resource allocation index (1=low 6=high) of Small states in 2010 to that in 2012?
Your response must be concise. 1.04. What is the ratio of the Resource allocation index (1=low 6=high) of Burundi in 2010 to that in 2012?
Make the answer very short. 0.95. What is the ratio of the Resource allocation index (1=low 6=high) in Pakistan in 2010 to that in 2012?
Give a very brief answer. 1.01. What is the ratio of the Resource allocation index (1=low 6=high) in Small states in 2010 to that in 2013?
Your answer should be compact. 1.04. What is the ratio of the Resource allocation index (1=low 6=high) of Burundi in 2010 to that in 2013?
Your answer should be compact. 0.95. What is the ratio of the Resource allocation index (1=low 6=high) of Pakistan in 2010 to that in 2013?
Keep it short and to the point. 1.01. What is the ratio of the Resource allocation index (1=low 6=high) of Small states in 2010 to that in 2014?
Ensure brevity in your answer.  1.05. What is the ratio of the Resource allocation index (1=low 6=high) of Burundi in 2010 to that in 2014?
Provide a short and direct response. 0.94. What is the ratio of the Resource allocation index (1=low 6=high) in Pakistan in 2010 to that in 2014?
Provide a short and direct response. 0.97. What is the ratio of the Resource allocation index (1=low 6=high) in Small states in 2011 to that in 2012?
Make the answer very short. 1.02. What is the ratio of the Resource allocation index (1=low 6=high) of Burundi in 2011 to that in 2012?
Your response must be concise. 0.96. What is the ratio of the Resource allocation index (1=low 6=high) in Pakistan in 2011 to that in 2012?
Offer a terse response. 1. What is the ratio of the Resource allocation index (1=low 6=high) of Small states in 2011 to that in 2013?
Offer a terse response. 1.03. What is the ratio of the Resource allocation index (1=low 6=high) of Burundi in 2011 to that in 2013?
Give a very brief answer. 0.96. What is the ratio of the Resource allocation index (1=low 6=high) of Small states in 2011 to that in 2014?
Keep it short and to the point. 1.03. What is the ratio of the Resource allocation index (1=low 6=high) of Burundi in 2011 to that in 2014?
Offer a very short reply. 0.95. What is the ratio of the Resource allocation index (1=low 6=high) of Pakistan in 2011 to that in 2014?
Your answer should be very brief. 0.97. What is the ratio of the Resource allocation index (1=low 6=high) in Burundi in 2012 to that in 2013?
Offer a terse response. 1. What is the ratio of the Resource allocation index (1=low 6=high) in Small states in 2012 to that in 2014?
Give a very brief answer. 1.01. What is the ratio of the Resource allocation index (1=low 6=high) of Burundi in 2012 to that in 2014?
Offer a very short reply. 0.99. What is the ratio of the Resource allocation index (1=low 6=high) in Pakistan in 2012 to that in 2014?
Ensure brevity in your answer.  0.97. What is the ratio of the Resource allocation index (1=low 6=high) in Small states in 2013 to that in 2014?
Offer a very short reply. 1.01. What is the ratio of the Resource allocation index (1=low 6=high) in Burundi in 2013 to that in 2014?
Keep it short and to the point. 0.99. What is the ratio of the Resource allocation index (1=low 6=high) of Pakistan in 2013 to that in 2014?
Provide a succinct answer. 0.97. What is the difference between the highest and the second highest Resource allocation index (1=low 6=high) of Small states?
Your answer should be very brief. 0.01. What is the difference between the highest and the second highest Resource allocation index (1=low 6=high) in Burundi?
Make the answer very short. 0.03. What is the difference between the highest and the second highest Resource allocation index (1=low 6=high) in Pakistan?
Give a very brief answer. 0.28. What is the difference between the highest and the lowest Resource allocation index (1=low 6=high) of Small states?
Your answer should be very brief. 0.16. What is the difference between the highest and the lowest Resource allocation index (1=low 6=high) in Burundi?
Offer a very short reply. 0.27. What is the difference between the highest and the lowest Resource allocation index (1=low 6=high) of Pakistan?
Your answer should be compact. 0.51. 